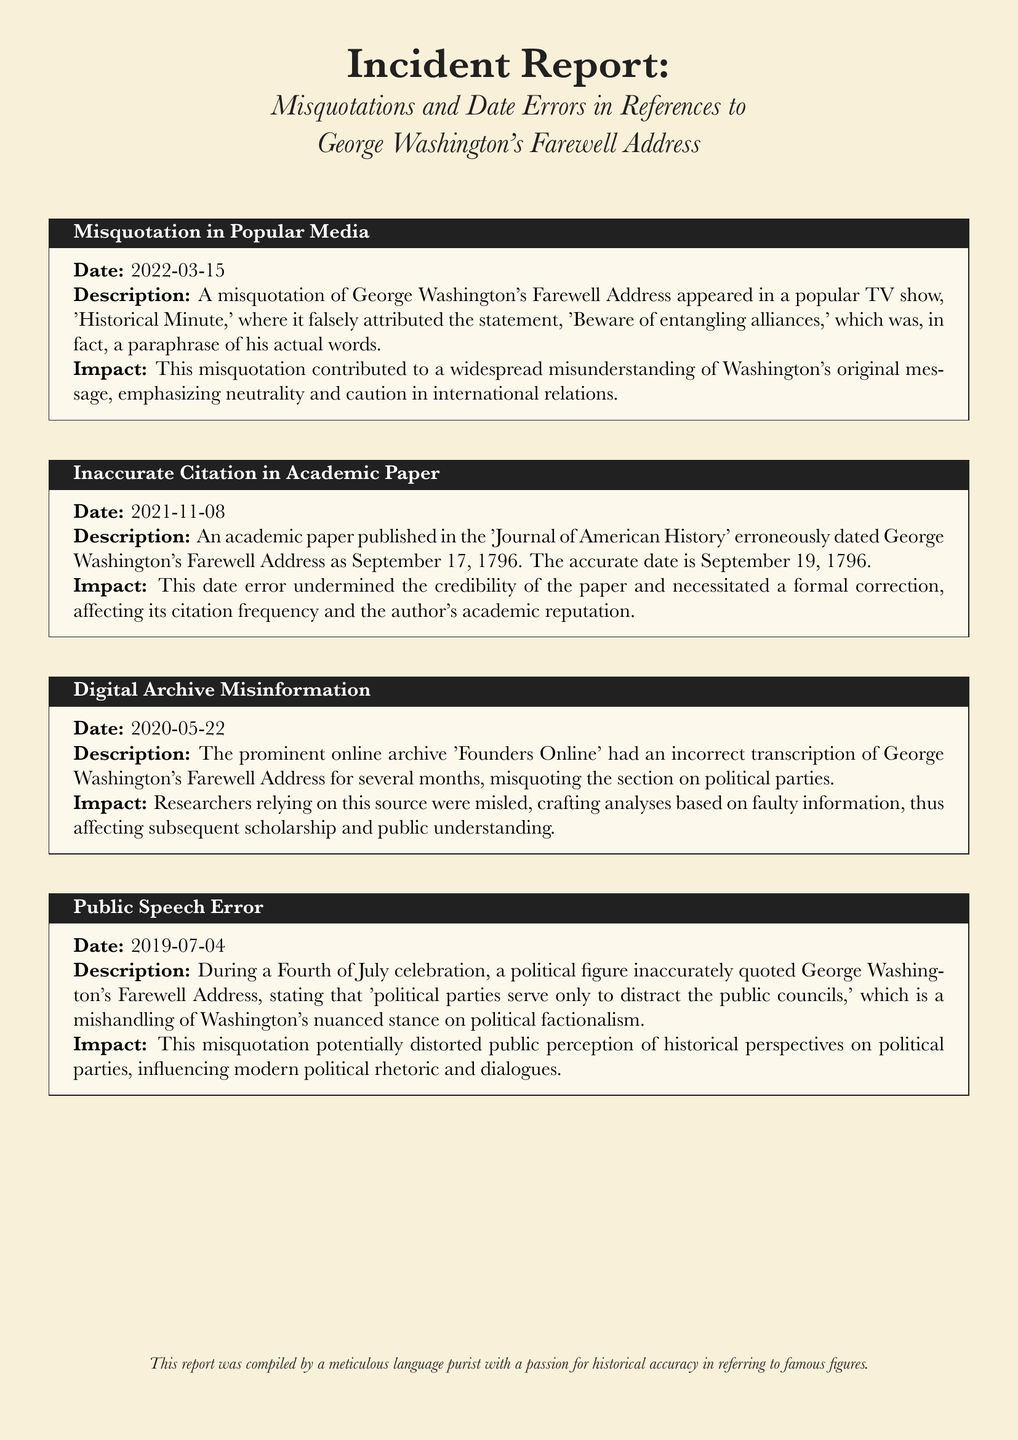What date was the misquotation incident reported? The report states that the misquotation incident occurred on March 15, 2022.
Answer: March 15, 2022 What was incorrectly cited in the academic paper? The academic paper incorrectly dated George Washington's Farewell Address, listing it as September 17, 1796 instead of the accurate September 19, 1796.
Answer: September 17, 1796 Which digital archive had misinformation about Washington's Farewell Address? The document mentions 'Founders Online' as the digital archive with incorrect transcription.
Answer: Founders Online What year did the public speech error occur? The public speech error took place during a Fourth of July celebration in 2019.
Answer: 2019 What statement was misquoted in the popular TV show? The misquoted statement was 'Beware of entangling alliances,' which was a paraphrase of Washington's actual words.
Answer: Beware of entangling alliances What was the impact of the misquotation on Washington's original message? The misquotation contributed to a widespread misunderstanding of Washington's original message about neutrality and caution in international relations.
Answer: Widespread misunderstanding What is the accurate date of George Washington's Farewell Address? The accurate date of the address is September 19, 1796, as stated in the incident regarding the inaccurate citation.
Answer: September 19, 1796 What was the effect of the digital archive error on researchers? Researchers relying on the incorrectly transcribed information were misled, affecting their analyses and subsequent scholarship.
Answer: Misled analyses Who compiled this incident report? The document indicates that the report was compiled by a meticulous language purist with a passion for historical accuracy.
Answer: A meticulous language purist 